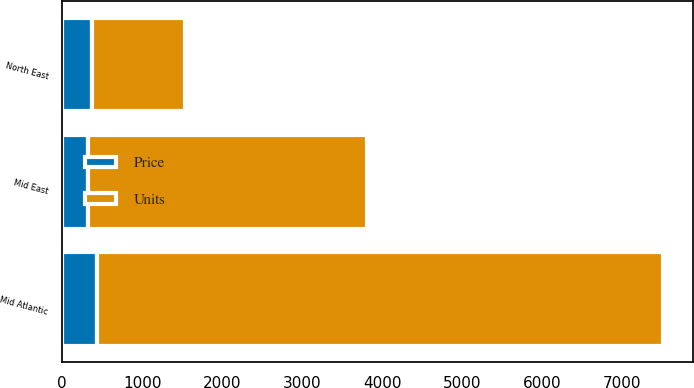<chart> <loc_0><loc_0><loc_500><loc_500><stacked_bar_chart><ecel><fcel>Mid Atlantic<fcel>North East<fcel>Mid East<nl><fcel>Units<fcel>7070<fcel>1173<fcel>3485<nl><fcel>Price<fcel>439.5<fcel>365.9<fcel>321.4<nl></chart> 